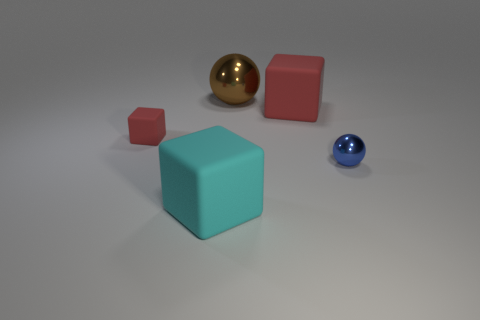Subtract all small rubber cubes. How many cubes are left? 2 Subtract 2 balls. How many balls are left? 0 Subtract all brown balls. How many balls are left? 1 Add 4 cyan rubber objects. How many objects exist? 9 Subtract all cubes. How many objects are left? 2 Subtract all small red cubes. Subtract all blue spheres. How many objects are left? 3 Add 5 brown metal things. How many brown metal things are left? 6 Add 2 big objects. How many big objects exist? 5 Subtract 0 yellow balls. How many objects are left? 5 Subtract all cyan spheres. Subtract all yellow cubes. How many spheres are left? 2 